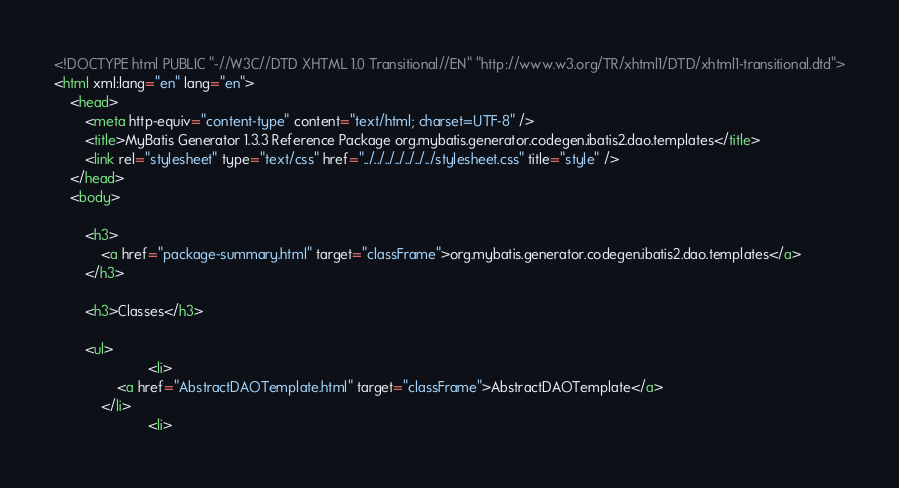Convert code to text. <code><loc_0><loc_0><loc_500><loc_500><_HTML_>
<!DOCTYPE html PUBLIC "-//W3C//DTD XHTML 1.0 Transitional//EN" "http://www.w3.org/TR/xhtml1/DTD/xhtml1-transitional.dtd">
<html xml:lang="en" lang="en">
	<head>
		<meta http-equiv="content-type" content="text/html; charset=UTF-8" />
		<title>MyBatis Generator 1.3.3 Reference Package org.mybatis.generator.codegen.ibatis2.dao.templates</title>
		<link rel="stylesheet" type="text/css" href="../../../../../../../stylesheet.css" title="style" />
	</head>
	<body>

		<h3>
        	<a href="package-summary.html" target="classFrame">org.mybatis.generator.codegen.ibatis2.dao.templates</a>
      	</h3>

      	<h3>Classes</h3>

      	<ul>
      		          	<li>
            	<a href="AbstractDAOTemplate.html" target="classFrame">AbstractDAOTemplate</a>
          	</li>
          	          	<li></code> 